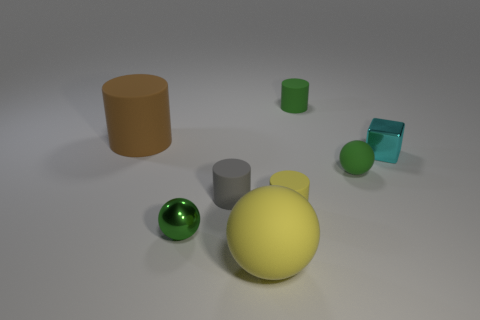There is a shiny object left of the tiny gray thing; does it have the same color as the small metallic cube?
Give a very brief answer. No. Are there more gray cylinders to the right of the tiny green rubber sphere than big brown rubber cylinders that are in front of the gray rubber cylinder?
Your response must be concise. No. Is the number of large cylinders greater than the number of large matte objects?
Provide a succinct answer. No. There is a green object that is in front of the small cyan object and behind the green metal ball; what is its size?
Ensure brevity in your answer.  Small. What is the shape of the cyan thing?
Provide a succinct answer. Cube. Is there any other thing that has the same size as the block?
Keep it short and to the point. Yes. Is the number of large things that are to the right of the big brown cylinder greater than the number of tiny cyan metallic blocks?
Keep it short and to the point. No. The metallic thing that is to the left of the yellow object that is in front of the tiny green sphere left of the small green cylinder is what shape?
Your answer should be compact. Sphere. Is the size of the sphere that is on the left side of the gray cylinder the same as the block?
Offer a very short reply. Yes. There is a green thing that is both in front of the cyan thing and right of the gray rubber thing; what is its shape?
Offer a terse response. Sphere. 